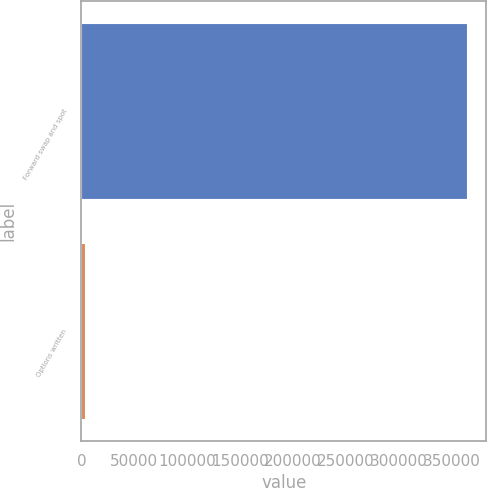Convert chart to OTSL. <chart><loc_0><loc_0><loc_500><loc_500><bar_chart><fcel>Forward swap and spot<fcel>Options written<nl><fcel>364357<fcel>3214<nl></chart> 